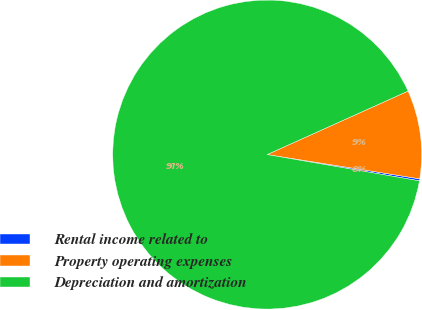Convert chart to OTSL. <chart><loc_0><loc_0><loc_500><loc_500><pie_chart><fcel>Rental income related to<fcel>Property operating expenses<fcel>Depreciation and amortization<nl><fcel>0.21%<fcel>9.25%<fcel>90.54%<nl></chart> 